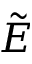Convert formula to latex. <formula><loc_0><loc_0><loc_500><loc_500>\tilde { E }</formula> 